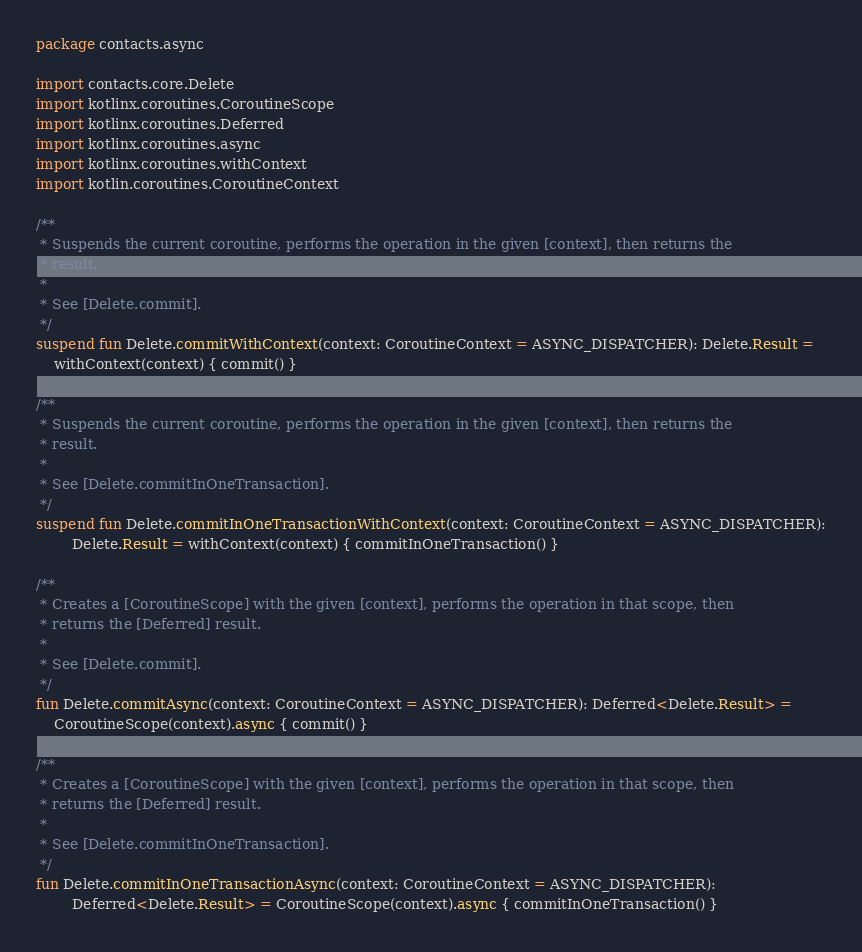Convert code to text. <code><loc_0><loc_0><loc_500><loc_500><_Kotlin_>package contacts.async

import contacts.core.Delete
import kotlinx.coroutines.CoroutineScope
import kotlinx.coroutines.Deferred
import kotlinx.coroutines.async
import kotlinx.coroutines.withContext
import kotlin.coroutines.CoroutineContext

/**
 * Suspends the current coroutine, performs the operation in the given [context], then returns the
 * result.
 *
 * See [Delete.commit].
 */
suspend fun Delete.commitWithContext(context: CoroutineContext = ASYNC_DISPATCHER): Delete.Result =
    withContext(context) { commit() }

/**
 * Suspends the current coroutine, performs the operation in the given [context], then returns the
 * result.
 *
 * See [Delete.commitInOneTransaction].
 */
suspend fun Delete.commitInOneTransactionWithContext(context: CoroutineContext = ASYNC_DISPATCHER):
        Delete.Result = withContext(context) { commitInOneTransaction() }

/**
 * Creates a [CoroutineScope] with the given [context], performs the operation in that scope, then
 * returns the [Deferred] result.
 *
 * See [Delete.commit].
 */
fun Delete.commitAsync(context: CoroutineContext = ASYNC_DISPATCHER): Deferred<Delete.Result> =
    CoroutineScope(context).async { commit() }

/**
 * Creates a [CoroutineScope] with the given [context], performs the operation in that scope, then
 * returns the [Deferred] result.
 *
 * See [Delete.commitInOneTransaction].
 */
fun Delete.commitInOneTransactionAsync(context: CoroutineContext = ASYNC_DISPATCHER):
        Deferred<Delete.Result> = CoroutineScope(context).async { commitInOneTransaction() }</code> 